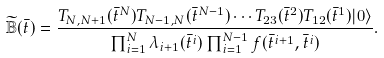Convert formula to latex. <formula><loc_0><loc_0><loc_500><loc_500>\widetilde { \mathbb { B } } ( \bar { t } ) = \frac { T _ { N , N + 1 } ( \bar { t } ^ { N } ) T _ { N - 1 , N } ( \bar { t } ^ { N - 1 } ) \cdots T _ { 2 3 } ( \bar { t } ^ { 2 } ) T _ { 1 2 } ( \bar { t } ^ { 1 } ) | 0 \rangle } { \prod _ { i = 1 } ^ { N } \lambda _ { i + 1 } ( \bar { t } ^ { i } ) \prod _ { i = 1 } ^ { N - 1 } f ( \bar { t } ^ { i + 1 } , \bar { t } ^ { i } ) } .</formula> 